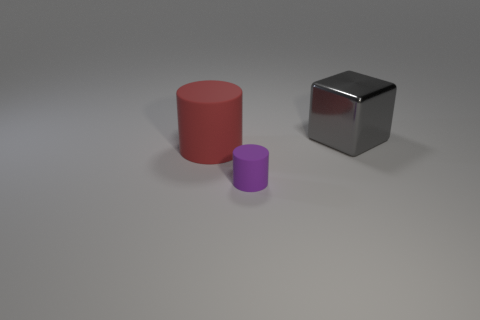Add 3 large things. How many objects exist? 6 Subtract all blocks. How many objects are left? 2 Add 2 gray shiny cylinders. How many gray shiny cylinders exist? 2 Subtract 0 blue cylinders. How many objects are left? 3 Subtract all large purple objects. Subtract all purple things. How many objects are left? 2 Add 2 red things. How many red things are left? 3 